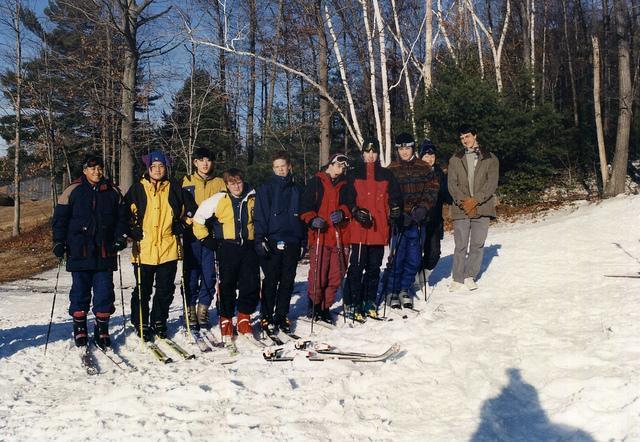How many people can you see?
Give a very brief answer. 10. How many bear arms are raised to the bears' ears?
Give a very brief answer. 0. 